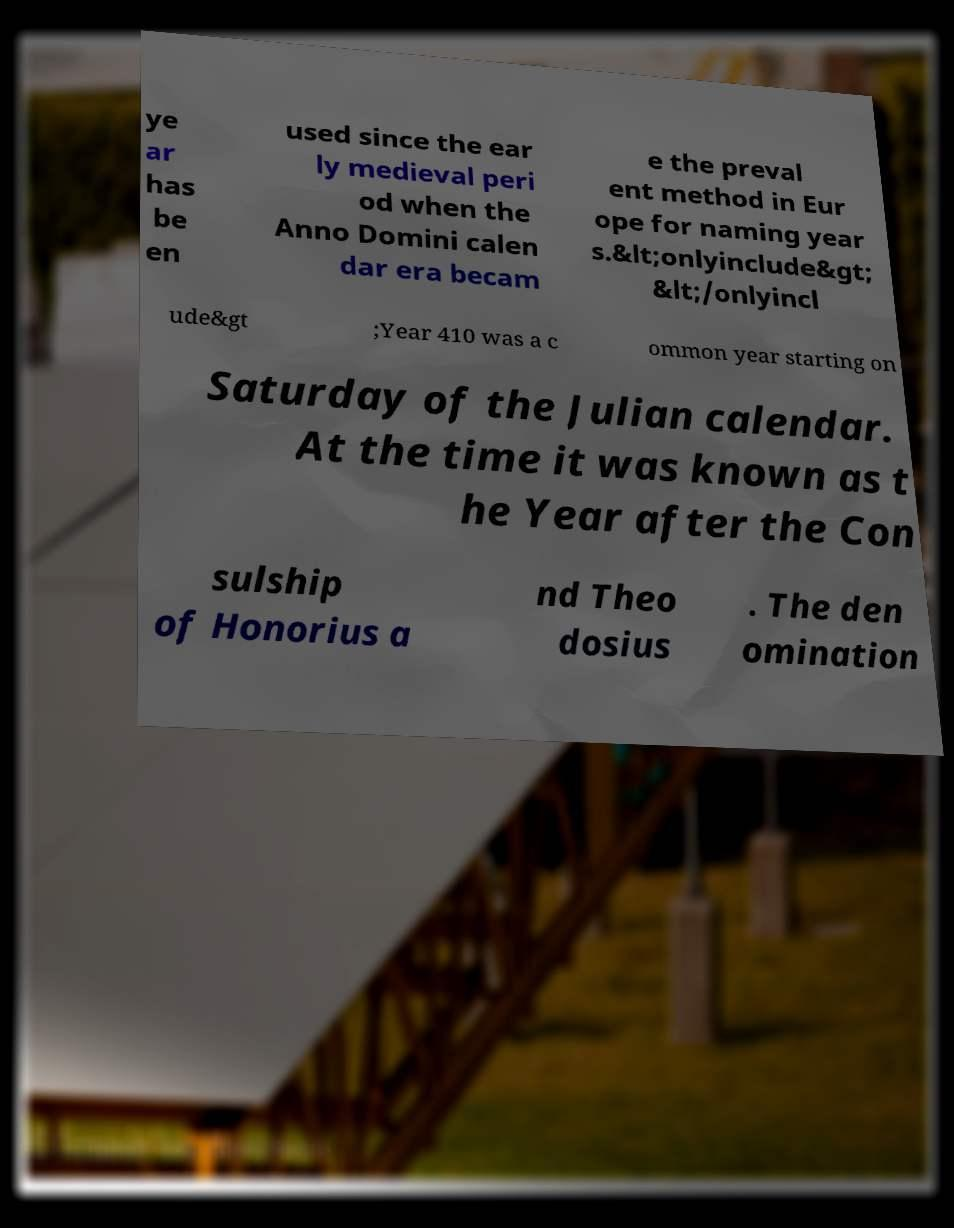I need the written content from this picture converted into text. Can you do that? ye ar has be en used since the ear ly medieval peri od when the Anno Domini calen dar era becam e the preval ent method in Eur ope for naming year s.&lt;onlyinclude&gt; &lt;/onlyincl ude&gt ;Year 410 was a c ommon year starting on Saturday of the Julian calendar. At the time it was known as t he Year after the Con sulship of Honorius a nd Theo dosius . The den omination 